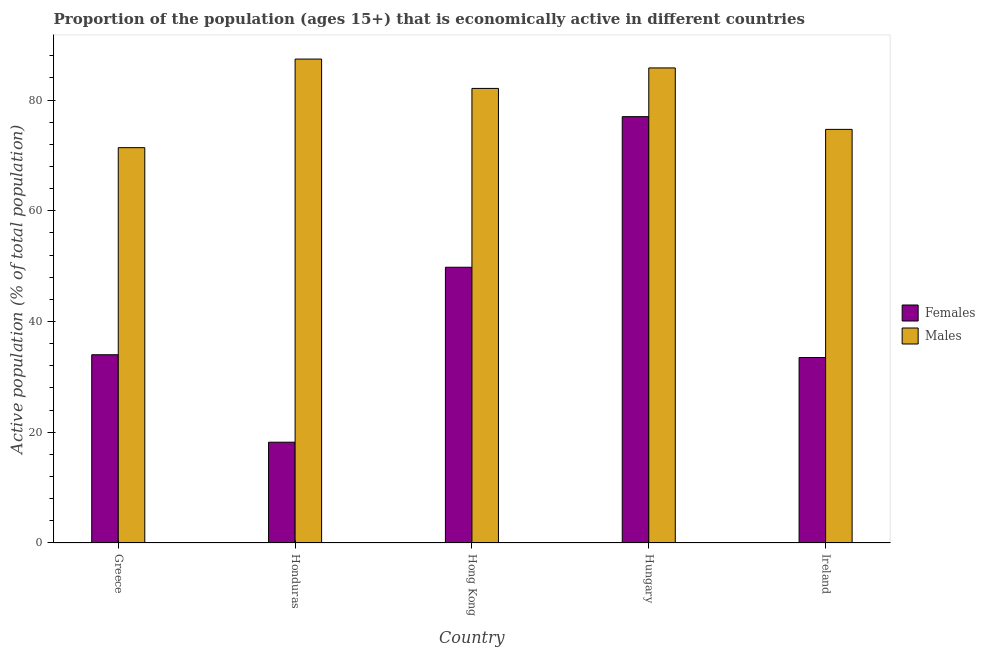How many groups of bars are there?
Provide a short and direct response. 5. Are the number of bars on each tick of the X-axis equal?
Give a very brief answer. Yes. How many bars are there on the 3rd tick from the left?
Your answer should be very brief. 2. What is the label of the 5th group of bars from the left?
Offer a terse response. Ireland. In how many cases, is the number of bars for a given country not equal to the number of legend labels?
Your answer should be compact. 0. What is the percentage of economically active female population in Hungary?
Your response must be concise. 77. Across all countries, what is the maximum percentage of economically active female population?
Keep it short and to the point. 77. Across all countries, what is the minimum percentage of economically active female population?
Your answer should be very brief. 18.2. In which country was the percentage of economically active female population maximum?
Your response must be concise. Hungary. In which country was the percentage of economically active male population minimum?
Your answer should be compact. Greece. What is the total percentage of economically active male population in the graph?
Provide a succinct answer. 401.4. What is the difference between the percentage of economically active male population in Greece and that in Hungary?
Offer a very short reply. -14.4. What is the difference between the percentage of economically active female population in Hungary and the percentage of economically active male population in Ireland?
Provide a short and direct response. 2.3. What is the average percentage of economically active female population per country?
Your answer should be compact. 42.5. What is the difference between the percentage of economically active male population and percentage of economically active female population in Ireland?
Your response must be concise. 41.2. In how many countries, is the percentage of economically active female population greater than 20 %?
Give a very brief answer. 4. What is the ratio of the percentage of economically active female population in Honduras to that in Ireland?
Give a very brief answer. 0.54. Is the percentage of economically active male population in Greece less than that in Hong Kong?
Provide a short and direct response. Yes. What is the difference between the highest and the second highest percentage of economically active male population?
Provide a short and direct response. 1.6. In how many countries, is the percentage of economically active male population greater than the average percentage of economically active male population taken over all countries?
Provide a succinct answer. 3. Is the sum of the percentage of economically active male population in Greece and Hungary greater than the maximum percentage of economically active female population across all countries?
Provide a short and direct response. Yes. What does the 1st bar from the left in Hungary represents?
Provide a succinct answer. Females. What does the 2nd bar from the right in Hungary represents?
Give a very brief answer. Females. How many bars are there?
Provide a short and direct response. 10. How many countries are there in the graph?
Provide a succinct answer. 5. What is the difference between two consecutive major ticks on the Y-axis?
Offer a terse response. 20. Are the values on the major ticks of Y-axis written in scientific E-notation?
Provide a succinct answer. No. How many legend labels are there?
Keep it short and to the point. 2. What is the title of the graph?
Your answer should be compact. Proportion of the population (ages 15+) that is economically active in different countries. Does "Investments" appear as one of the legend labels in the graph?
Your answer should be very brief. No. What is the label or title of the Y-axis?
Keep it short and to the point. Active population (% of total population). What is the Active population (% of total population) of Males in Greece?
Your response must be concise. 71.4. What is the Active population (% of total population) of Females in Honduras?
Make the answer very short. 18.2. What is the Active population (% of total population) of Males in Honduras?
Ensure brevity in your answer.  87.4. What is the Active population (% of total population) of Females in Hong Kong?
Ensure brevity in your answer.  49.8. What is the Active population (% of total population) of Males in Hong Kong?
Your answer should be very brief. 82.1. What is the Active population (% of total population) in Females in Hungary?
Your answer should be compact. 77. What is the Active population (% of total population) in Males in Hungary?
Give a very brief answer. 85.8. What is the Active population (% of total population) in Females in Ireland?
Provide a short and direct response. 33.5. What is the Active population (% of total population) in Males in Ireland?
Ensure brevity in your answer.  74.7. Across all countries, what is the maximum Active population (% of total population) of Males?
Your answer should be compact. 87.4. Across all countries, what is the minimum Active population (% of total population) of Females?
Provide a succinct answer. 18.2. Across all countries, what is the minimum Active population (% of total population) of Males?
Provide a succinct answer. 71.4. What is the total Active population (% of total population) of Females in the graph?
Provide a succinct answer. 212.5. What is the total Active population (% of total population) in Males in the graph?
Offer a very short reply. 401.4. What is the difference between the Active population (% of total population) of Males in Greece and that in Honduras?
Keep it short and to the point. -16. What is the difference between the Active population (% of total population) of Females in Greece and that in Hong Kong?
Offer a very short reply. -15.8. What is the difference between the Active population (% of total population) in Males in Greece and that in Hong Kong?
Offer a terse response. -10.7. What is the difference between the Active population (% of total population) in Females in Greece and that in Hungary?
Your response must be concise. -43. What is the difference between the Active population (% of total population) in Males in Greece and that in Hungary?
Make the answer very short. -14.4. What is the difference between the Active population (% of total population) in Females in Greece and that in Ireland?
Your response must be concise. 0.5. What is the difference between the Active population (% of total population) of Males in Greece and that in Ireland?
Give a very brief answer. -3.3. What is the difference between the Active population (% of total population) in Females in Honduras and that in Hong Kong?
Make the answer very short. -31.6. What is the difference between the Active population (% of total population) in Females in Honduras and that in Hungary?
Provide a short and direct response. -58.8. What is the difference between the Active population (% of total population) of Males in Honduras and that in Hungary?
Offer a terse response. 1.6. What is the difference between the Active population (% of total population) in Females in Honduras and that in Ireland?
Provide a succinct answer. -15.3. What is the difference between the Active population (% of total population) in Males in Honduras and that in Ireland?
Your answer should be compact. 12.7. What is the difference between the Active population (% of total population) of Females in Hong Kong and that in Hungary?
Your answer should be very brief. -27.2. What is the difference between the Active population (% of total population) in Males in Hong Kong and that in Hungary?
Your response must be concise. -3.7. What is the difference between the Active population (% of total population) in Females in Hong Kong and that in Ireland?
Offer a very short reply. 16.3. What is the difference between the Active population (% of total population) in Males in Hong Kong and that in Ireland?
Ensure brevity in your answer.  7.4. What is the difference between the Active population (% of total population) in Females in Hungary and that in Ireland?
Provide a short and direct response. 43.5. What is the difference between the Active population (% of total population) in Females in Greece and the Active population (% of total population) in Males in Honduras?
Your answer should be compact. -53.4. What is the difference between the Active population (% of total population) in Females in Greece and the Active population (% of total population) in Males in Hong Kong?
Your answer should be very brief. -48.1. What is the difference between the Active population (% of total population) in Females in Greece and the Active population (% of total population) in Males in Hungary?
Provide a succinct answer. -51.8. What is the difference between the Active population (% of total population) of Females in Greece and the Active population (% of total population) of Males in Ireland?
Offer a very short reply. -40.7. What is the difference between the Active population (% of total population) in Females in Honduras and the Active population (% of total population) in Males in Hong Kong?
Keep it short and to the point. -63.9. What is the difference between the Active population (% of total population) in Females in Honduras and the Active population (% of total population) in Males in Hungary?
Provide a short and direct response. -67.6. What is the difference between the Active population (% of total population) of Females in Honduras and the Active population (% of total population) of Males in Ireland?
Provide a succinct answer. -56.5. What is the difference between the Active population (% of total population) in Females in Hong Kong and the Active population (% of total population) in Males in Hungary?
Offer a terse response. -36. What is the difference between the Active population (% of total population) in Females in Hong Kong and the Active population (% of total population) in Males in Ireland?
Provide a short and direct response. -24.9. What is the average Active population (% of total population) of Females per country?
Your answer should be compact. 42.5. What is the average Active population (% of total population) of Males per country?
Your response must be concise. 80.28. What is the difference between the Active population (% of total population) in Females and Active population (% of total population) in Males in Greece?
Keep it short and to the point. -37.4. What is the difference between the Active population (% of total population) in Females and Active population (% of total population) in Males in Honduras?
Ensure brevity in your answer.  -69.2. What is the difference between the Active population (% of total population) of Females and Active population (% of total population) of Males in Hong Kong?
Make the answer very short. -32.3. What is the difference between the Active population (% of total population) of Females and Active population (% of total population) of Males in Hungary?
Give a very brief answer. -8.8. What is the difference between the Active population (% of total population) of Females and Active population (% of total population) of Males in Ireland?
Your response must be concise. -41.2. What is the ratio of the Active population (% of total population) in Females in Greece to that in Honduras?
Your answer should be compact. 1.87. What is the ratio of the Active population (% of total population) in Males in Greece to that in Honduras?
Provide a short and direct response. 0.82. What is the ratio of the Active population (% of total population) in Females in Greece to that in Hong Kong?
Provide a succinct answer. 0.68. What is the ratio of the Active population (% of total population) in Males in Greece to that in Hong Kong?
Your response must be concise. 0.87. What is the ratio of the Active population (% of total population) in Females in Greece to that in Hungary?
Offer a very short reply. 0.44. What is the ratio of the Active population (% of total population) in Males in Greece to that in Hungary?
Give a very brief answer. 0.83. What is the ratio of the Active population (% of total population) in Females in Greece to that in Ireland?
Provide a short and direct response. 1.01. What is the ratio of the Active population (% of total population) in Males in Greece to that in Ireland?
Ensure brevity in your answer.  0.96. What is the ratio of the Active population (% of total population) of Females in Honduras to that in Hong Kong?
Provide a succinct answer. 0.37. What is the ratio of the Active population (% of total population) of Males in Honduras to that in Hong Kong?
Keep it short and to the point. 1.06. What is the ratio of the Active population (% of total population) of Females in Honduras to that in Hungary?
Your answer should be compact. 0.24. What is the ratio of the Active population (% of total population) in Males in Honduras to that in Hungary?
Ensure brevity in your answer.  1.02. What is the ratio of the Active population (% of total population) of Females in Honduras to that in Ireland?
Offer a terse response. 0.54. What is the ratio of the Active population (% of total population) in Males in Honduras to that in Ireland?
Your answer should be very brief. 1.17. What is the ratio of the Active population (% of total population) in Females in Hong Kong to that in Hungary?
Provide a succinct answer. 0.65. What is the ratio of the Active population (% of total population) in Males in Hong Kong to that in Hungary?
Keep it short and to the point. 0.96. What is the ratio of the Active population (% of total population) of Females in Hong Kong to that in Ireland?
Your answer should be very brief. 1.49. What is the ratio of the Active population (% of total population) of Males in Hong Kong to that in Ireland?
Provide a short and direct response. 1.1. What is the ratio of the Active population (% of total population) in Females in Hungary to that in Ireland?
Make the answer very short. 2.3. What is the ratio of the Active population (% of total population) of Males in Hungary to that in Ireland?
Provide a short and direct response. 1.15. What is the difference between the highest and the second highest Active population (% of total population) of Females?
Your answer should be very brief. 27.2. What is the difference between the highest and the lowest Active population (% of total population) of Females?
Offer a very short reply. 58.8. What is the difference between the highest and the lowest Active population (% of total population) in Males?
Offer a very short reply. 16. 